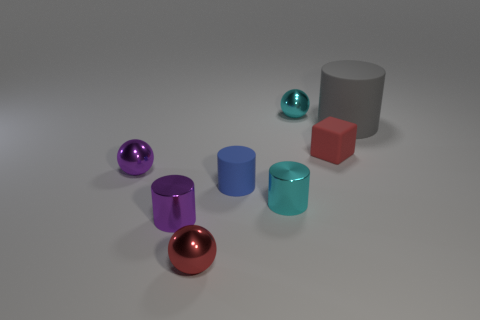What number of things are tiny spheres or small metallic objects in front of the blue object?
Ensure brevity in your answer.  5. Are there more gray rubber cylinders that are in front of the tiny cyan cylinder than tiny blocks to the right of the small matte cube?
Provide a succinct answer. No. The red object that is behind the red thing in front of the tiny cylinder on the right side of the blue matte thing is what shape?
Offer a very short reply. Cube. The tiny red thing to the right of the small red object to the left of the small cyan sphere is what shape?
Give a very brief answer. Cube. Is there another small blue cylinder made of the same material as the tiny blue cylinder?
Your answer should be compact. No. There is a metal thing that is the same color as the tiny rubber block; what is its size?
Your answer should be very brief. Small. What number of brown things are either tiny metallic balls or big objects?
Keep it short and to the point. 0. Are there any matte cubes of the same color as the big object?
Your answer should be compact. No. There is a cyan thing that is the same material as the cyan ball; what size is it?
Your answer should be compact. Small. What number of balls are either large red metallic objects or small metal objects?
Provide a succinct answer. 3. 